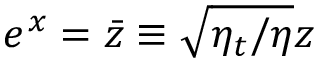<formula> <loc_0><loc_0><loc_500><loc_500>e ^ { x } = \ B a r { z } \equiv \sqrt { \eta _ { t } / \eta } z</formula> 